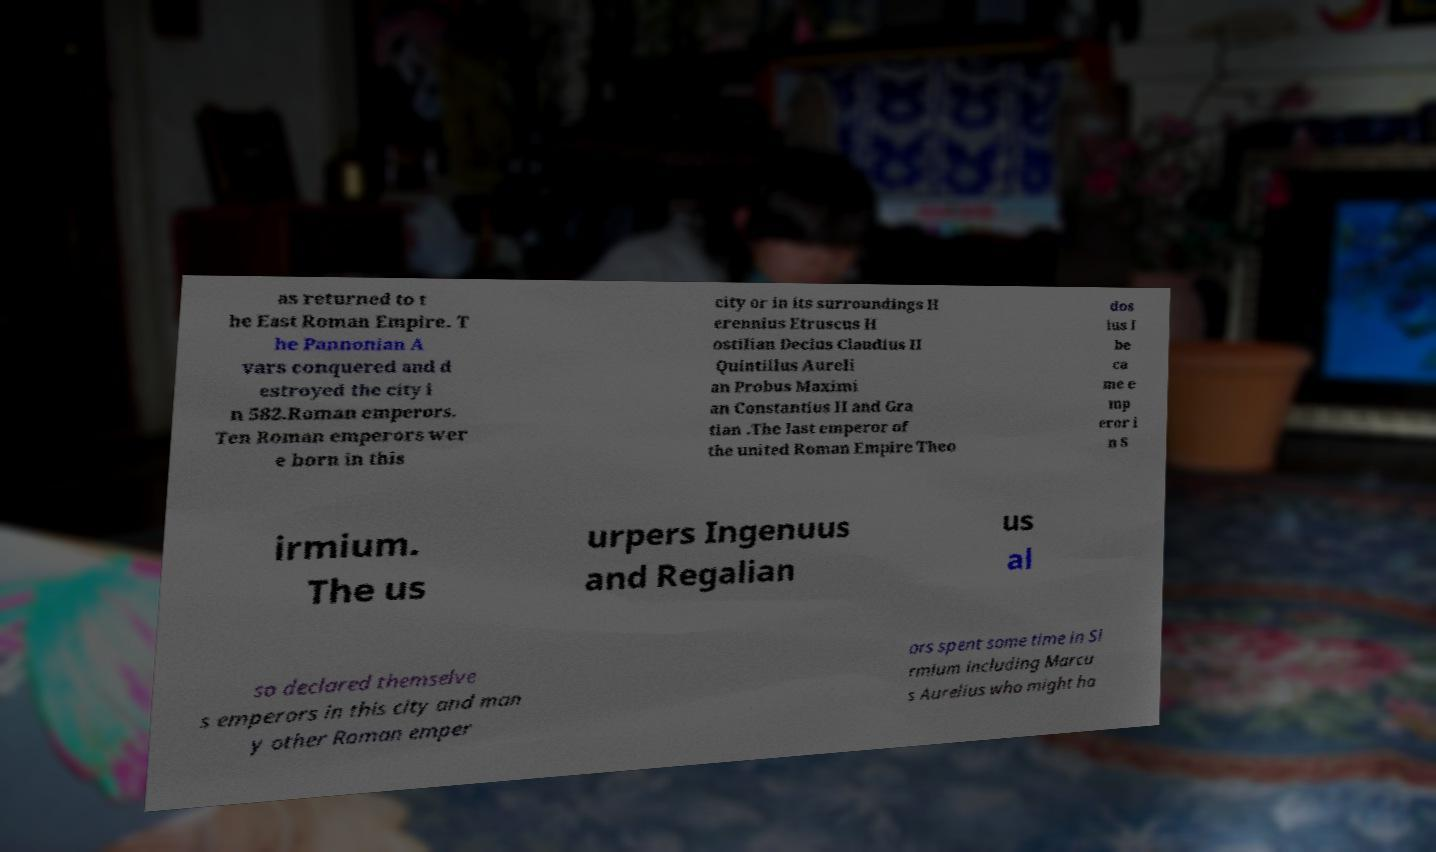There's text embedded in this image that I need extracted. Can you transcribe it verbatim? as returned to t he East Roman Empire. T he Pannonian A vars conquered and d estroyed the city i n 582.Roman emperors. Ten Roman emperors wer e born in this city or in its surroundings H erennius Etruscus H ostilian Decius Claudius II Quintillus Aureli an Probus Maximi an Constantius II and Gra tian .The last emperor of the united Roman Empire Theo dos ius I be ca me e mp eror i n S irmium. The us urpers Ingenuus and Regalian us al so declared themselve s emperors in this city and man y other Roman emper ors spent some time in Si rmium including Marcu s Aurelius who might ha 